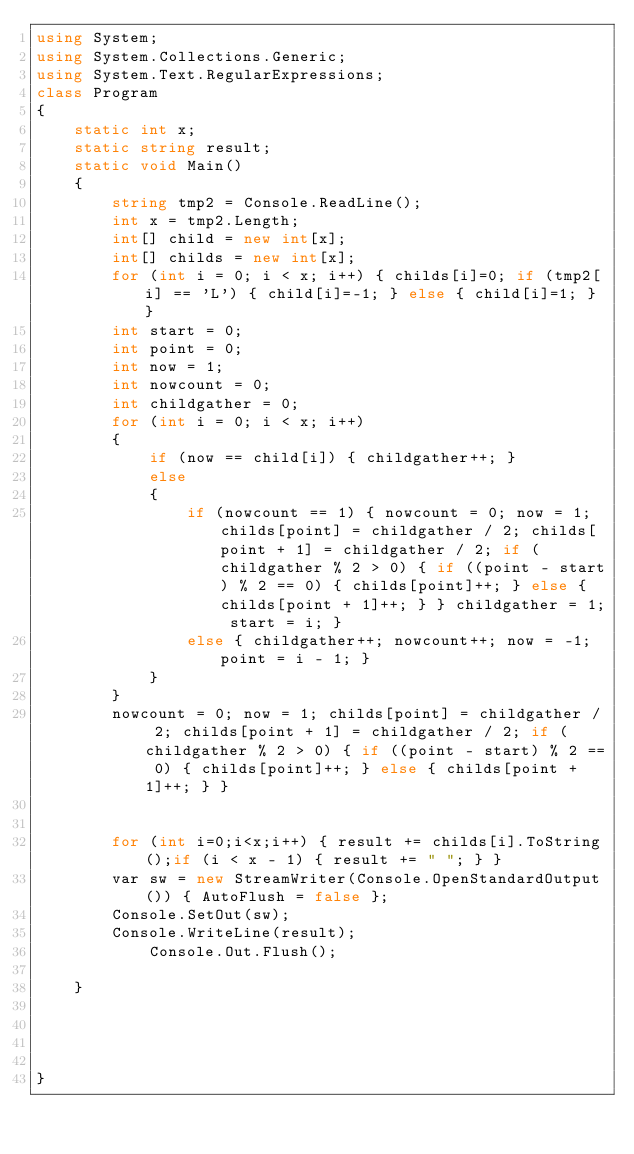Convert code to text. <code><loc_0><loc_0><loc_500><loc_500><_C#_>using System;
using System.Collections.Generic;
using System.Text.RegularExpressions;
class Program
{
    static int x;
    static string result;
    static void Main()
    {
        string tmp2 = Console.ReadLine();
        int x = tmp2.Length;
        int[] child = new int[x];
        int[] childs = new int[x];
        for (int i = 0; i < x; i++) { childs[i]=0; if (tmp2[i] == 'L') { child[i]=-1; } else { child[i]=1; } }
        int start = 0;
        int point = 0;
        int now = 1;
        int nowcount = 0;
        int childgather = 0;
        for (int i = 0; i < x; i++)
        {
            if (now == child[i]) { childgather++; }
            else
            {
                if (nowcount == 1) { nowcount = 0; now = 1; childs[point] = childgather / 2; childs[point + 1] = childgather / 2; if (childgather % 2 > 0) { if ((point - start) % 2 == 0) { childs[point]++; } else { childs[point + 1]++; } } childgather = 1; start = i; }
                else { childgather++; nowcount++; now = -1; point = i - 1; }
            }
        }
        nowcount = 0; now = 1; childs[point] = childgather / 2; childs[point + 1] = childgather / 2; if (childgather % 2 > 0) { if ((point - start) % 2 == 0) { childs[point]++; } else { childs[point + 1]++; } }


        for (int i=0;i<x;i++) { result += childs[i].ToString();if (i < x - 1) { result += " "; } }
        var sw = new StreamWriter(Console.OpenStandardOutput()) { AutoFlush = false };
        Console.SetOut(sw);
        Console.WriteLine(result);
            Console.Out.Flush();
        
    }

 


}</code> 